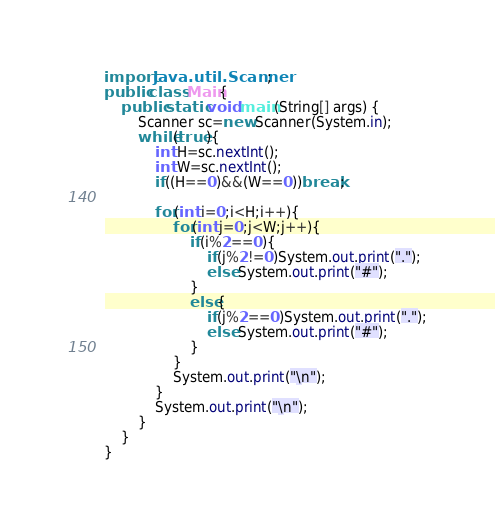Convert code to text. <code><loc_0><loc_0><loc_500><loc_500><_Java_>import java.util.Scanner;
public class Main{
    public static void main(String[] args) {
        Scanner sc=new Scanner(System.in);
        while(true){
            int H=sc.nextInt();
            int W=sc.nextInt();
            if((H==0)&&(W==0))break;

            for(int i=0;i<H;i++){
                for(int j=0;j<W;j++){
                    if(i%2==0){
                        if(j%2!=0)System.out.print(".");
                        else System.out.print("#");
                    }
                    else{
                        if(j%2==0)System.out.print(".");
                        else System.out.print("#");
                    }
                }
                System.out.print("\n");
            }
            System.out.print("\n");
        }
    }
}
</code> 